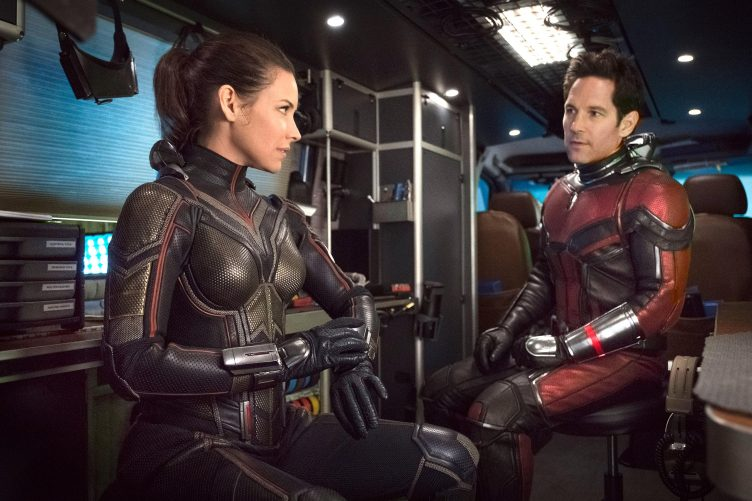Describe the following image. This image captures a scene with two actors portraying characters from the movie 'Ant-Man and the Wasp'. The actors are seated inside a high-tech vehicle, surrounded by a vivid display of blue and orange lights, adding an intense, dynamic quality to the scene. On the left, the actress, dressed as the Wasp, appears poised and alert, her posture rigid yet ready, reflecting her character's resilience and readiness for action. On the right, the actor playing Ant-Man exhibits a relaxed yet attentive posture, symbolizing his character's approachable yet heroic nature. Their focused gazes towards each other suggest a moment of serious discussion or decision-making, hinting at the complexities of their teamwork and the challenges they face together. 